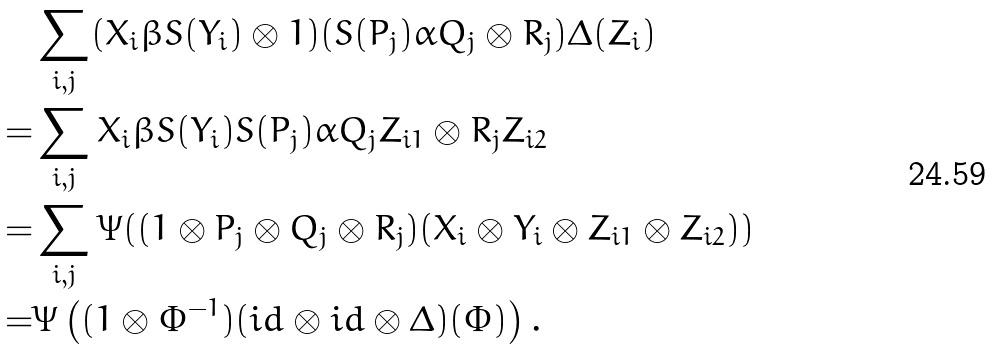Convert formula to latex. <formula><loc_0><loc_0><loc_500><loc_500>& \sum _ { i , j } ( X _ { i } \beta S ( Y _ { i } ) \otimes 1 ) ( S ( P _ { j } ) \alpha Q _ { j } \otimes R _ { j } ) \Delta ( Z _ { i } ) \\ = & \sum _ { i , j } X _ { i } \beta S ( Y _ { i } ) S ( P _ { j } ) \alpha Q _ { j } Z _ { i 1 } \otimes R _ { j } Z _ { i 2 } \\ = & \sum _ { i , j } \Psi ( ( 1 \otimes P _ { j } \otimes Q _ { j } \otimes R _ { j } ) ( X _ { i } \otimes Y _ { i } \otimes Z _ { i 1 } \otimes Z _ { i 2 } ) ) \\ = & \Psi \left ( ( 1 \otimes \Phi ^ { - 1 } ) ( i d \otimes i d \otimes \Delta ) ( \Phi ) \right ) .</formula> 